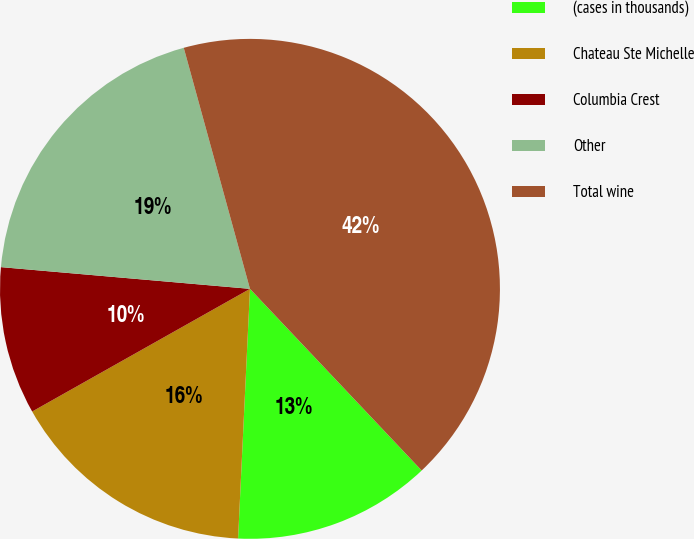Convert chart. <chart><loc_0><loc_0><loc_500><loc_500><pie_chart><fcel>(cases in thousands)<fcel>Chateau Ste Michelle<fcel>Columbia Crest<fcel>Other<fcel>Total wine<nl><fcel>12.81%<fcel>16.08%<fcel>9.55%<fcel>19.35%<fcel>42.22%<nl></chart> 